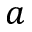<formula> <loc_0><loc_0><loc_500><loc_500>a</formula> 